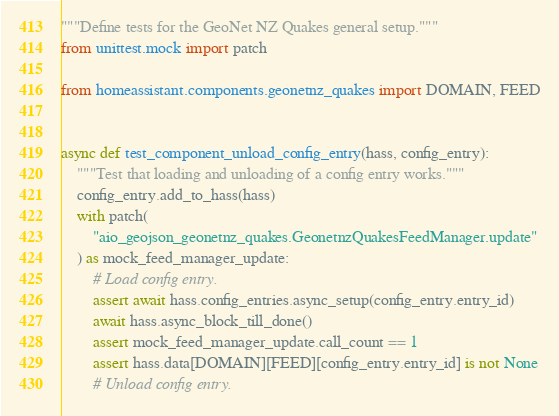Convert code to text. <code><loc_0><loc_0><loc_500><loc_500><_Python_>"""Define tests for the GeoNet NZ Quakes general setup."""
from unittest.mock import patch

from homeassistant.components.geonetnz_quakes import DOMAIN, FEED


async def test_component_unload_config_entry(hass, config_entry):
    """Test that loading and unloading of a config entry works."""
    config_entry.add_to_hass(hass)
    with patch(
        "aio_geojson_geonetnz_quakes.GeonetnzQuakesFeedManager.update"
    ) as mock_feed_manager_update:
        # Load config entry.
        assert await hass.config_entries.async_setup(config_entry.entry_id)
        await hass.async_block_till_done()
        assert mock_feed_manager_update.call_count == 1
        assert hass.data[DOMAIN][FEED][config_entry.entry_id] is not None
        # Unload config entry.</code> 